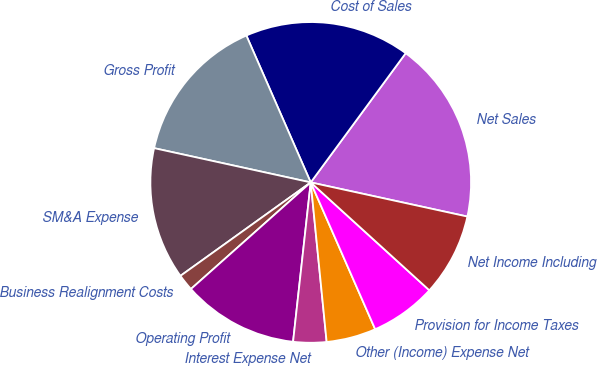Convert chart. <chart><loc_0><loc_0><loc_500><loc_500><pie_chart><fcel>Net Sales<fcel>Cost of Sales<fcel>Gross Profit<fcel>SM&A Expense<fcel>Business Realignment Costs<fcel>Operating Profit<fcel>Interest Expense Net<fcel>Other (Income) Expense Net<fcel>Provision for Income Taxes<fcel>Net Income Including<nl><fcel>18.33%<fcel>16.66%<fcel>15.0%<fcel>13.33%<fcel>1.67%<fcel>11.67%<fcel>3.34%<fcel>5.0%<fcel>6.67%<fcel>8.33%<nl></chart> 